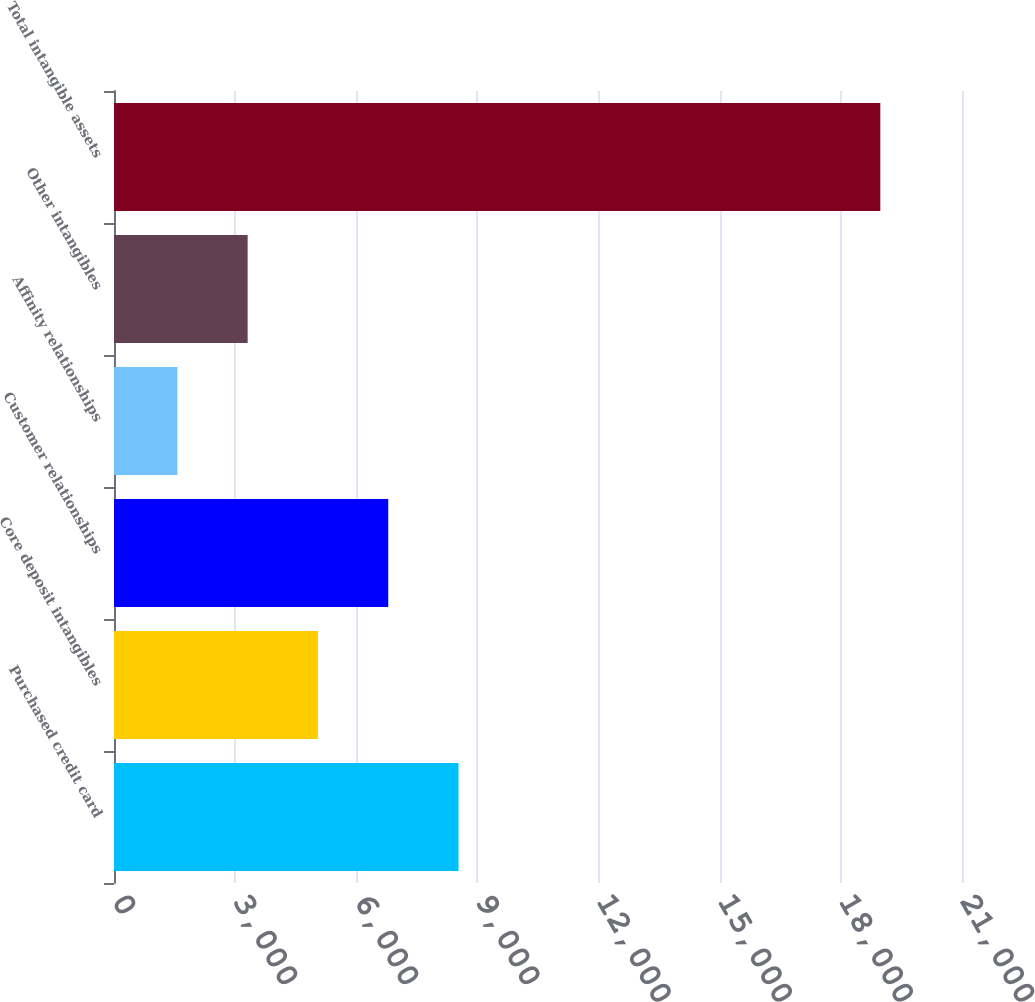<chart> <loc_0><loc_0><loc_500><loc_500><bar_chart><fcel>Purchased credit card<fcel>Core deposit intangibles<fcel>Customer relationships<fcel>Affinity relationships<fcel>Other intangibles<fcel>Total intangible assets<nl><fcel>8532.2<fcel>5050.6<fcel>6791.4<fcel>1569<fcel>3309.8<fcel>18977<nl></chart> 